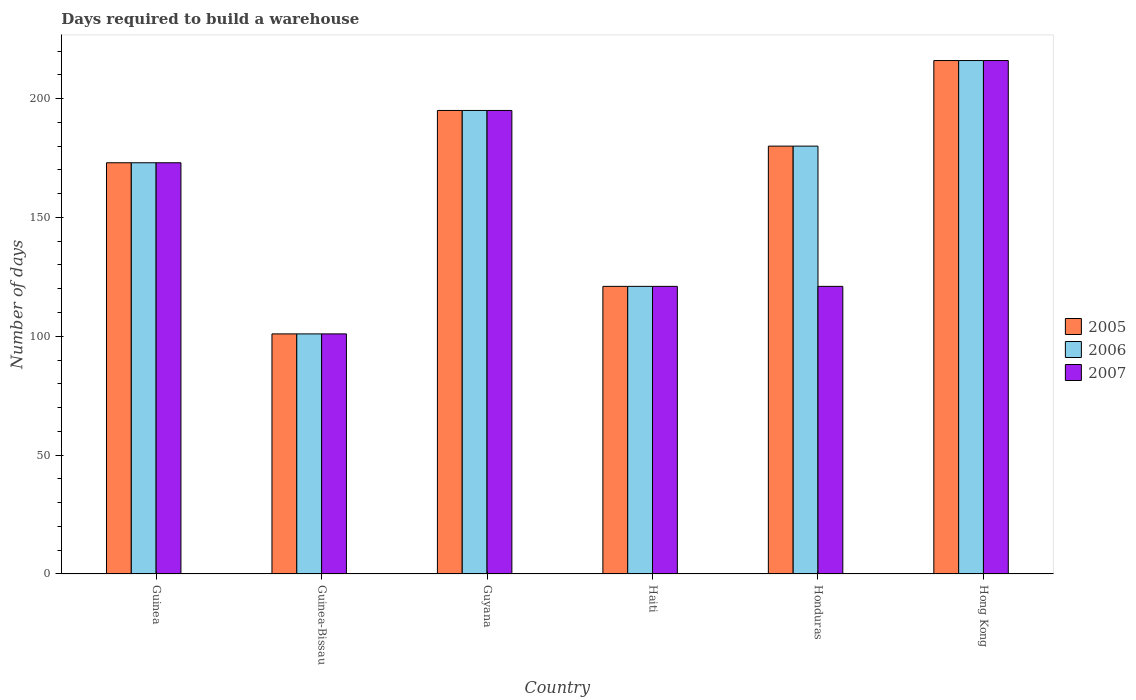How many groups of bars are there?
Your response must be concise. 6. Are the number of bars per tick equal to the number of legend labels?
Your answer should be very brief. Yes. How many bars are there on the 4th tick from the left?
Make the answer very short. 3. What is the label of the 6th group of bars from the left?
Make the answer very short. Hong Kong. What is the days required to build a warehouse in in 2005 in Honduras?
Your answer should be compact. 180. Across all countries, what is the maximum days required to build a warehouse in in 2005?
Make the answer very short. 216. Across all countries, what is the minimum days required to build a warehouse in in 2006?
Your answer should be compact. 101. In which country was the days required to build a warehouse in in 2005 maximum?
Your answer should be compact. Hong Kong. In which country was the days required to build a warehouse in in 2007 minimum?
Your answer should be compact. Guinea-Bissau. What is the total days required to build a warehouse in in 2007 in the graph?
Keep it short and to the point. 927. What is the difference between the days required to build a warehouse in in 2005 in Guinea and that in Honduras?
Keep it short and to the point. -7. What is the difference between the days required to build a warehouse in in 2007 in Guinea-Bissau and the days required to build a warehouse in in 2006 in Hong Kong?
Offer a terse response. -115. What is the average days required to build a warehouse in in 2007 per country?
Give a very brief answer. 154.5. What is the difference between the days required to build a warehouse in of/in 2005 and days required to build a warehouse in of/in 2007 in Guinea-Bissau?
Offer a very short reply. 0. What is the ratio of the days required to build a warehouse in in 2006 in Guyana to that in Hong Kong?
Provide a succinct answer. 0.9. Is the days required to build a warehouse in in 2006 in Haiti less than that in Hong Kong?
Make the answer very short. Yes. Is the difference between the days required to build a warehouse in in 2005 in Guinea-Bissau and Guyana greater than the difference between the days required to build a warehouse in in 2007 in Guinea-Bissau and Guyana?
Give a very brief answer. No. What is the difference between the highest and the second highest days required to build a warehouse in in 2005?
Give a very brief answer. 21. What is the difference between the highest and the lowest days required to build a warehouse in in 2007?
Provide a succinct answer. 115. In how many countries, is the days required to build a warehouse in in 2006 greater than the average days required to build a warehouse in in 2006 taken over all countries?
Provide a succinct answer. 4. What does the 1st bar from the right in Honduras represents?
Ensure brevity in your answer.  2007. How many bars are there?
Provide a short and direct response. 18. What is the difference between two consecutive major ticks on the Y-axis?
Offer a terse response. 50. Are the values on the major ticks of Y-axis written in scientific E-notation?
Your answer should be very brief. No. How many legend labels are there?
Provide a short and direct response. 3. How are the legend labels stacked?
Make the answer very short. Vertical. What is the title of the graph?
Ensure brevity in your answer.  Days required to build a warehouse. What is the label or title of the Y-axis?
Provide a succinct answer. Number of days. What is the Number of days of 2005 in Guinea?
Make the answer very short. 173. What is the Number of days in 2006 in Guinea?
Your answer should be compact. 173. What is the Number of days of 2007 in Guinea?
Ensure brevity in your answer.  173. What is the Number of days in 2005 in Guinea-Bissau?
Offer a terse response. 101. What is the Number of days in 2006 in Guinea-Bissau?
Offer a terse response. 101. What is the Number of days of 2007 in Guinea-Bissau?
Make the answer very short. 101. What is the Number of days of 2005 in Guyana?
Your answer should be compact. 195. What is the Number of days in 2006 in Guyana?
Make the answer very short. 195. What is the Number of days in 2007 in Guyana?
Your answer should be very brief. 195. What is the Number of days of 2005 in Haiti?
Keep it short and to the point. 121. What is the Number of days of 2006 in Haiti?
Offer a terse response. 121. What is the Number of days in 2007 in Haiti?
Your response must be concise. 121. What is the Number of days of 2005 in Honduras?
Give a very brief answer. 180. What is the Number of days of 2006 in Honduras?
Keep it short and to the point. 180. What is the Number of days of 2007 in Honduras?
Your answer should be very brief. 121. What is the Number of days of 2005 in Hong Kong?
Provide a succinct answer. 216. What is the Number of days of 2006 in Hong Kong?
Keep it short and to the point. 216. What is the Number of days in 2007 in Hong Kong?
Make the answer very short. 216. Across all countries, what is the maximum Number of days of 2005?
Offer a very short reply. 216. Across all countries, what is the maximum Number of days in 2006?
Make the answer very short. 216. Across all countries, what is the maximum Number of days in 2007?
Ensure brevity in your answer.  216. Across all countries, what is the minimum Number of days in 2005?
Give a very brief answer. 101. Across all countries, what is the minimum Number of days of 2006?
Your response must be concise. 101. Across all countries, what is the minimum Number of days of 2007?
Provide a succinct answer. 101. What is the total Number of days in 2005 in the graph?
Provide a succinct answer. 986. What is the total Number of days in 2006 in the graph?
Offer a terse response. 986. What is the total Number of days in 2007 in the graph?
Offer a terse response. 927. What is the difference between the Number of days of 2005 in Guinea and that in Guinea-Bissau?
Your answer should be compact. 72. What is the difference between the Number of days of 2005 in Guinea and that in Guyana?
Keep it short and to the point. -22. What is the difference between the Number of days in 2007 in Guinea and that in Guyana?
Provide a short and direct response. -22. What is the difference between the Number of days in 2006 in Guinea and that in Haiti?
Give a very brief answer. 52. What is the difference between the Number of days in 2007 in Guinea and that in Haiti?
Give a very brief answer. 52. What is the difference between the Number of days in 2006 in Guinea and that in Honduras?
Give a very brief answer. -7. What is the difference between the Number of days of 2007 in Guinea and that in Honduras?
Your answer should be compact. 52. What is the difference between the Number of days of 2005 in Guinea and that in Hong Kong?
Give a very brief answer. -43. What is the difference between the Number of days of 2006 in Guinea and that in Hong Kong?
Make the answer very short. -43. What is the difference between the Number of days in 2007 in Guinea and that in Hong Kong?
Give a very brief answer. -43. What is the difference between the Number of days of 2005 in Guinea-Bissau and that in Guyana?
Offer a very short reply. -94. What is the difference between the Number of days of 2006 in Guinea-Bissau and that in Guyana?
Provide a succinct answer. -94. What is the difference between the Number of days of 2007 in Guinea-Bissau and that in Guyana?
Your response must be concise. -94. What is the difference between the Number of days of 2006 in Guinea-Bissau and that in Haiti?
Offer a terse response. -20. What is the difference between the Number of days of 2005 in Guinea-Bissau and that in Honduras?
Offer a very short reply. -79. What is the difference between the Number of days of 2006 in Guinea-Bissau and that in Honduras?
Your answer should be compact. -79. What is the difference between the Number of days of 2005 in Guinea-Bissau and that in Hong Kong?
Provide a short and direct response. -115. What is the difference between the Number of days in 2006 in Guinea-Bissau and that in Hong Kong?
Offer a terse response. -115. What is the difference between the Number of days of 2007 in Guinea-Bissau and that in Hong Kong?
Keep it short and to the point. -115. What is the difference between the Number of days in 2005 in Guyana and that in Haiti?
Offer a terse response. 74. What is the difference between the Number of days of 2006 in Guyana and that in Haiti?
Your response must be concise. 74. What is the difference between the Number of days in 2007 in Guyana and that in Haiti?
Provide a succinct answer. 74. What is the difference between the Number of days in 2006 in Guyana and that in Honduras?
Give a very brief answer. 15. What is the difference between the Number of days of 2005 in Guyana and that in Hong Kong?
Your answer should be very brief. -21. What is the difference between the Number of days of 2006 in Guyana and that in Hong Kong?
Keep it short and to the point. -21. What is the difference between the Number of days in 2005 in Haiti and that in Honduras?
Offer a very short reply. -59. What is the difference between the Number of days of 2006 in Haiti and that in Honduras?
Provide a succinct answer. -59. What is the difference between the Number of days of 2007 in Haiti and that in Honduras?
Ensure brevity in your answer.  0. What is the difference between the Number of days of 2005 in Haiti and that in Hong Kong?
Provide a short and direct response. -95. What is the difference between the Number of days of 2006 in Haiti and that in Hong Kong?
Provide a succinct answer. -95. What is the difference between the Number of days in 2007 in Haiti and that in Hong Kong?
Keep it short and to the point. -95. What is the difference between the Number of days in 2005 in Honduras and that in Hong Kong?
Offer a terse response. -36. What is the difference between the Number of days of 2006 in Honduras and that in Hong Kong?
Ensure brevity in your answer.  -36. What is the difference between the Number of days of 2007 in Honduras and that in Hong Kong?
Your answer should be very brief. -95. What is the difference between the Number of days in 2005 in Guinea and the Number of days in 2007 in Guinea-Bissau?
Your answer should be compact. 72. What is the difference between the Number of days of 2005 in Guinea and the Number of days of 2006 in Guyana?
Ensure brevity in your answer.  -22. What is the difference between the Number of days in 2006 in Guinea and the Number of days in 2007 in Guyana?
Keep it short and to the point. -22. What is the difference between the Number of days of 2005 in Guinea and the Number of days of 2006 in Haiti?
Ensure brevity in your answer.  52. What is the difference between the Number of days of 2006 in Guinea and the Number of days of 2007 in Haiti?
Your answer should be very brief. 52. What is the difference between the Number of days of 2005 in Guinea and the Number of days of 2007 in Honduras?
Ensure brevity in your answer.  52. What is the difference between the Number of days of 2006 in Guinea and the Number of days of 2007 in Honduras?
Provide a short and direct response. 52. What is the difference between the Number of days in 2005 in Guinea and the Number of days in 2006 in Hong Kong?
Give a very brief answer. -43. What is the difference between the Number of days in 2005 in Guinea and the Number of days in 2007 in Hong Kong?
Ensure brevity in your answer.  -43. What is the difference between the Number of days of 2006 in Guinea and the Number of days of 2007 in Hong Kong?
Your answer should be compact. -43. What is the difference between the Number of days in 2005 in Guinea-Bissau and the Number of days in 2006 in Guyana?
Provide a succinct answer. -94. What is the difference between the Number of days of 2005 in Guinea-Bissau and the Number of days of 2007 in Guyana?
Ensure brevity in your answer.  -94. What is the difference between the Number of days of 2006 in Guinea-Bissau and the Number of days of 2007 in Guyana?
Keep it short and to the point. -94. What is the difference between the Number of days of 2005 in Guinea-Bissau and the Number of days of 2006 in Haiti?
Your response must be concise. -20. What is the difference between the Number of days in 2005 in Guinea-Bissau and the Number of days in 2006 in Honduras?
Keep it short and to the point. -79. What is the difference between the Number of days in 2006 in Guinea-Bissau and the Number of days in 2007 in Honduras?
Keep it short and to the point. -20. What is the difference between the Number of days in 2005 in Guinea-Bissau and the Number of days in 2006 in Hong Kong?
Your answer should be compact. -115. What is the difference between the Number of days of 2005 in Guinea-Bissau and the Number of days of 2007 in Hong Kong?
Ensure brevity in your answer.  -115. What is the difference between the Number of days in 2006 in Guinea-Bissau and the Number of days in 2007 in Hong Kong?
Offer a very short reply. -115. What is the difference between the Number of days of 2005 in Guyana and the Number of days of 2006 in Haiti?
Ensure brevity in your answer.  74. What is the difference between the Number of days in 2005 in Guyana and the Number of days in 2007 in Haiti?
Your answer should be compact. 74. What is the difference between the Number of days of 2006 in Guyana and the Number of days of 2007 in Honduras?
Provide a succinct answer. 74. What is the difference between the Number of days of 2005 in Haiti and the Number of days of 2006 in Honduras?
Provide a short and direct response. -59. What is the difference between the Number of days of 2005 in Haiti and the Number of days of 2007 in Honduras?
Provide a succinct answer. 0. What is the difference between the Number of days of 2006 in Haiti and the Number of days of 2007 in Honduras?
Your answer should be compact. 0. What is the difference between the Number of days in 2005 in Haiti and the Number of days in 2006 in Hong Kong?
Make the answer very short. -95. What is the difference between the Number of days of 2005 in Haiti and the Number of days of 2007 in Hong Kong?
Your answer should be very brief. -95. What is the difference between the Number of days of 2006 in Haiti and the Number of days of 2007 in Hong Kong?
Give a very brief answer. -95. What is the difference between the Number of days of 2005 in Honduras and the Number of days of 2006 in Hong Kong?
Offer a terse response. -36. What is the difference between the Number of days in 2005 in Honduras and the Number of days in 2007 in Hong Kong?
Your answer should be compact. -36. What is the difference between the Number of days of 2006 in Honduras and the Number of days of 2007 in Hong Kong?
Provide a short and direct response. -36. What is the average Number of days of 2005 per country?
Offer a very short reply. 164.33. What is the average Number of days of 2006 per country?
Ensure brevity in your answer.  164.33. What is the average Number of days in 2007 per country?
Provide a succinct answer. 154.5. What is the difference between the Number of days of 2005 and Number of days of 2006 in Guinea?
Provide a short and direct response. 0. What is the difference between the Number of days of 2006 and Number of days of 2007 in Guinea?
Your answer should be compact. 0. What is the difference between the Number of days of 2005 and Number of days of 2006 in Guinea-Bissau?
Your answer should be compact. 0. What is the difference between the Number of days of 2005 and Number of days of 2007 in Guinea-Bissau?
Your answer should be compact. 0. What is the difference between the Number of days in 2006 and Number of days in 2007 in Guinea-Bissau?
Offer a terse response. 0. What is the difference between the Number of days in 2005 and Number of days in 2007 in Guyana?
Your answer should be compact. 0. What is the difference between the Number of days of 2005 and Number of days of 2006 in Haiti?
Your response must be concise. 0. What is the difference between the Number of days of 2005 and Number of days of 2007 in Haiti?
Your response must be concise. 0. What is the difference between the Number of days in 2005 and Number of days in 2006 in Honduras?
Your answer should be very brief. 0. What is the difference between the Number of days in 2006 and Number of days in 2007 in Honduras?
Keep it short and to the point. 59. What is the difference between the Number of days in 2005 and Number of days in 2007 in Hong Kong?
Offer a very short reply. 0. What is the ratio of the Number of days of 2005 in Guinea to that in Guinea-Bissau?
Offer a very short reply. 1.71. What is the ratio of the Number of days in 2006 in Guinea to that in Guinea-Bissau?
Offer a very short reply. 1.71. What is the ratio of the Number of days in 2007 in Guinea to that in Guinea-Bissau?
Your answer should be compact. 1.71. What is the ratio of the Number of days in 2005 in Guinea to that in Guyana?
Your answer should be compact. 0.89. What is the ratio of the Number of days of 2006 in Guinea to that in Guyana?
Keep it short and to the point. 0.89. What is the ratio of the Number of days of 2007 in Guinea to that in Guyana?
Provide a succinct answer. 0.89. What is the ratio of the Number of days in 2005 in Guinea to that in Haiti?
Ensure brevity in your answer.  1.43. What is the ratio of the Number of days in 2006 in Guinea to that in Haiti?
Your answer should be compact. 1.43. What is the ratio of the Number of days of 2007 in Guinea to that in Haiti?
Provide a short and direct response. 1.43. What is the ratio of the Number of days of 2005 in Guinea to that in Honduras?
Keep it short and to the point. 0.96. What is the ratio of the Number of days of 2006 in Guinea to that in Honduras?
Keep it short and to the point. 0.96. What is the ratio of the Number of days in 2007 in Guinea to that in Honduras?
Keep it short and to the point. 1.43. What is the ratio of the Number of days in 2005 in Guinea to that in Hong Kong?
Make the answer very short. 0.8. What is the ratio of the Number of days in 2006 in Guinea to that in Hong Kong?
Your response must be concise. 0.8. What is the ratio of the Number of days in 2007 in Guinea to that in Hong Kong?
Provide a short and direct response. 0.8. What is the ratio of the Number of days in 2005 in Guinea-Bissau to that in Guyana?
Give a very brief answer. 0.52. What is the ratio of the Number of days of 2006 in Guinea-Bissau to that in Guyana?
Give a very brief answer. 0.52. What is the ratio of the Number of days in 2007 in Guinea-Bissau to that in Guyana?
Offer a terse response. 0.52. What is the ratio of the Number of days of 2005 in Guinea-Bissau to that in Haiti?
Give a very brief answer. 0.83. What is the ratio of the Number of days in 2006 in Guinea-Bissau to that in Haiti?
Your response must be concise. 0.83. What is the ratio of the Number of days in 2007 in Guinea-Bissau to that in Haiti?
Ensure brevity in your answer.  0.83. What is the ratio of the Number of days in 2005 in Guinea-Bissau to that in Honduras?
Offer a very short reply. 0.56. What is the ratio of the Number of days in 2006 in Guinea-Bissau to that in Honduras?
Make the answer very short. 0.56. What is the ratio of the Number of days of 2007 in Guinea-Bissau to that in Honduras?
Give a very brief answer. 0.83. What is the ratio of the Number of days in 2005 in Guinea-Bissau to that in Hong Kong?
Offer a very short reply. 0.47. What is the ratio of the Number of days of 2006 in Guinea-Bissau to that in Hong Kong?
Your answer should be very brief. 0.47. What is the ratio of the Number of days of 2007 in Guinea-Bissau to that in Hong Kong?
Ensure brevity in your answer.  0.47. What is the ratio of the Number of days of 2005 in Guyana to that in Haiti?
Offer a terse response. 1.61. What is the ratio of the Number of days in 2006 in Guyana to that in Haiti?
Your answer should be very brief. 1.61. What is the ratio of the Number of days of 2007 in Guyana to that in Haiti?
Provide a short and direct response. 1.61. What is the ratio of the Number of days of 2005 in Guyana to that in Honduras?
Provide a short and direct response. 1.08. What is the ratio of the Number of days in 2006 in Guyana to that in Honduras?
Provide a succinct answer. 1.08. What is the ratio of the Number of days of 2007 in Guyana to that in Honduras?
Give a very brief answer. 1.61. What is the ratio of the Number of days in 2005 in Guyana to that in Hong Kong?
Offer a very short reply. 0.9. What is the ratio of the Number of days of 2006 in Guyana to that in Hong Kong?
Keep it short and to the point. 0.9. What is the ratio of the Number of days of 2007 in Guyana to that in Hong Kong?
Your answer should be very brief. 0.9. What is the ratio of the Number of days in 2005 in Haiti to that in Honduras?
Give a very brief answer. 0.67. What is the ratio of the Number of days in 2006 in Haiti to that in Honduras?
Offer a very short reply. 0.67. What is the ratio of the Number of days in 2007 in Haiti to that in Honduras?
Offer a very short reply. 1. What is the ratio of the Number of days of 2005 in Haiti to that in Hong Kong?
Keep it short and to the point. 0.56. What is the ratio of the Number of days in 2006 in Haiti to that in Hong Kong?
Give a very brief answer. 0.56. What is the ratio of the Number of days in 2007 in Haiti to that in Hong Kong?
Provide a short and direct response. 0.56. What is the ratio of the Number of days in 2005 in Honduras to that in Hong Kong?
Keep it short and to the point. 0.83. What is the ratio of the Number of days of 2006 in Honduras to that in Hong Kong?
Keep it short and to the point. 0.83. What is the ratio of the Number of days of 2007 in Honduras to that in Hong Kong?
Offer a very short reply. 0.56. What is the difference between the highest and the second highest Number of days in 2005?
Make the answer very short. 21. What is the difference between the highest and the second highest Number of days in 2007?
Give a very brief answer. 21. What is the difference between the highest and the lowest Number of days of 2005?
Make the answer very short. 115. What is the difference between the highest and the lowest Number of days in 2006?
Your answer should be compact. 115. What is the difference between the highest and the lowest Number of days of 2007?
Give a very brief answer. 115. 